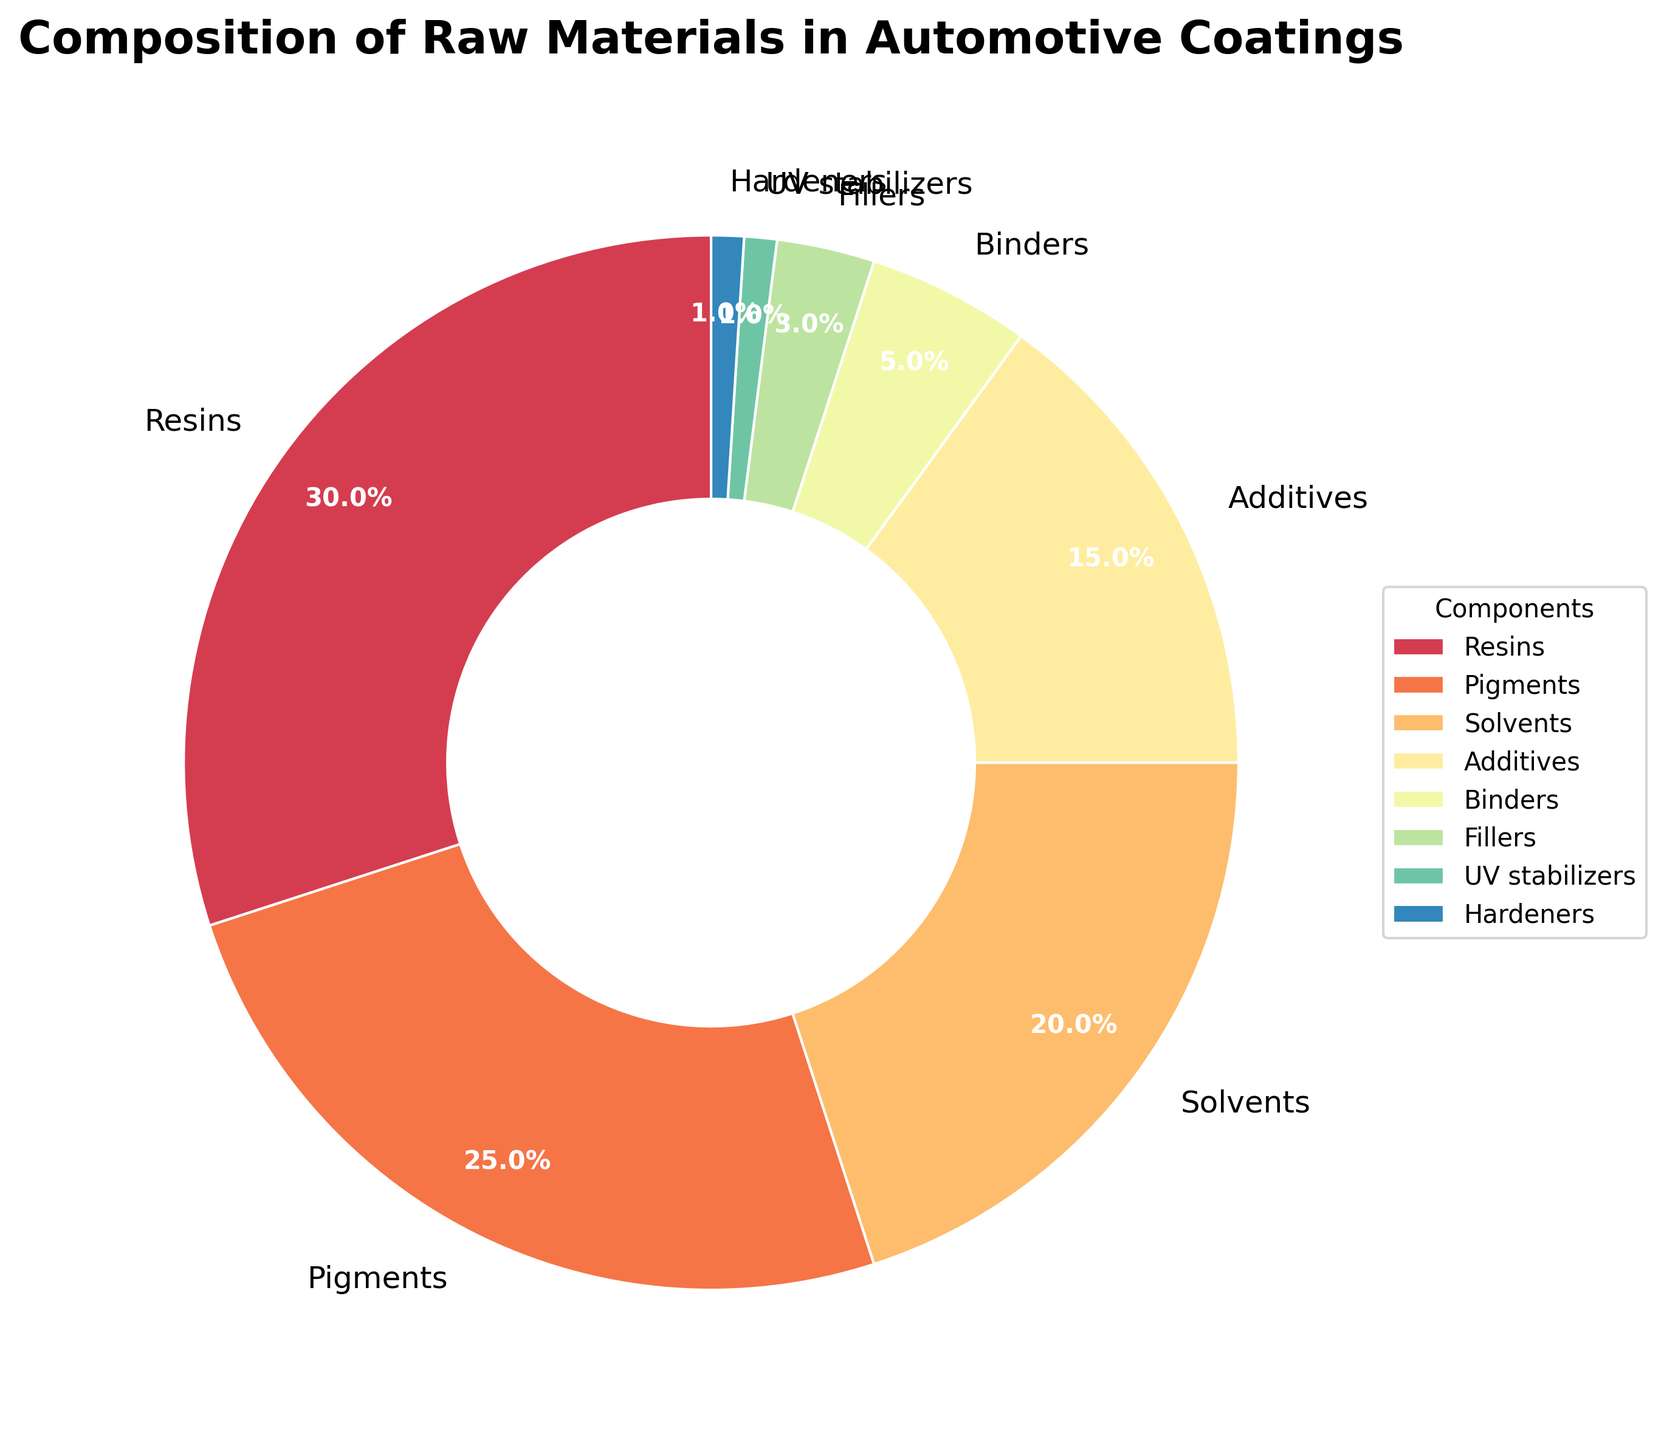What is the total percentage of resins, pigments, and solvents combined? To find the total percentage of resins, pigments, and solvents combined, add their individual percentages: Resins (30%) + Pigments (25%) + Solvents (20%) = 75%.
Answer: 75% Which component has the smallest percentage in the composition? To determine the smallest component, look at the components and their percentages. UV stabilizers and Hardeners both have 1%, which is the smallest.
Answer: UV stabilizers and Hardeners Is the percentage of pigments greater than the percentage of solvents? Compare the percentages of pigments (25%) and solvents (20%) directly. Since 25% is greater than 20%, the answer is yes.
Answer: Yes What is the difference in percentage between additives and fillers? Subtract the percentage of fillers (3%) from the percentage of additives (15%) to find the difference: 15% - 3% = 12%.
Answer: 12% Do UV stabilizers and hardeners together make up more than binders? Add the percentages of UV stabilizers (1%) and hardeners (1%) first, which equals 2%. Then compare this to binders (5%). Since 2% is less than 5%, the answer is no.
Answer: No What percentage of the composition is due to components that each contribute more than 10%? Identify the components that contribute more than 10%: Resins (30%), Pigments (25%), Solvents (20%), and Additives (15%). Now add their percentages: 30% + 25% + 20% + 15% = 90%.
Answer: 90% If the resin percentage was reduced by 10%, how would that affect the overall composition? Subtract 10% from the resin percentage (30%) to get the new percentage: 30% - 10% = 20%. The total percentage of all components would remain 100%, but the individual percentages would adjust accordingly.
Answer: The resin percentage would decrease to 20% Which component takes a light red wedge in the chart? Identifying the component by its visual attribute involves recognizing the light red color wedge in the chart, which corresponds to Pigments (25%) from the pie chart shading scheme.
Answer: Pigments 